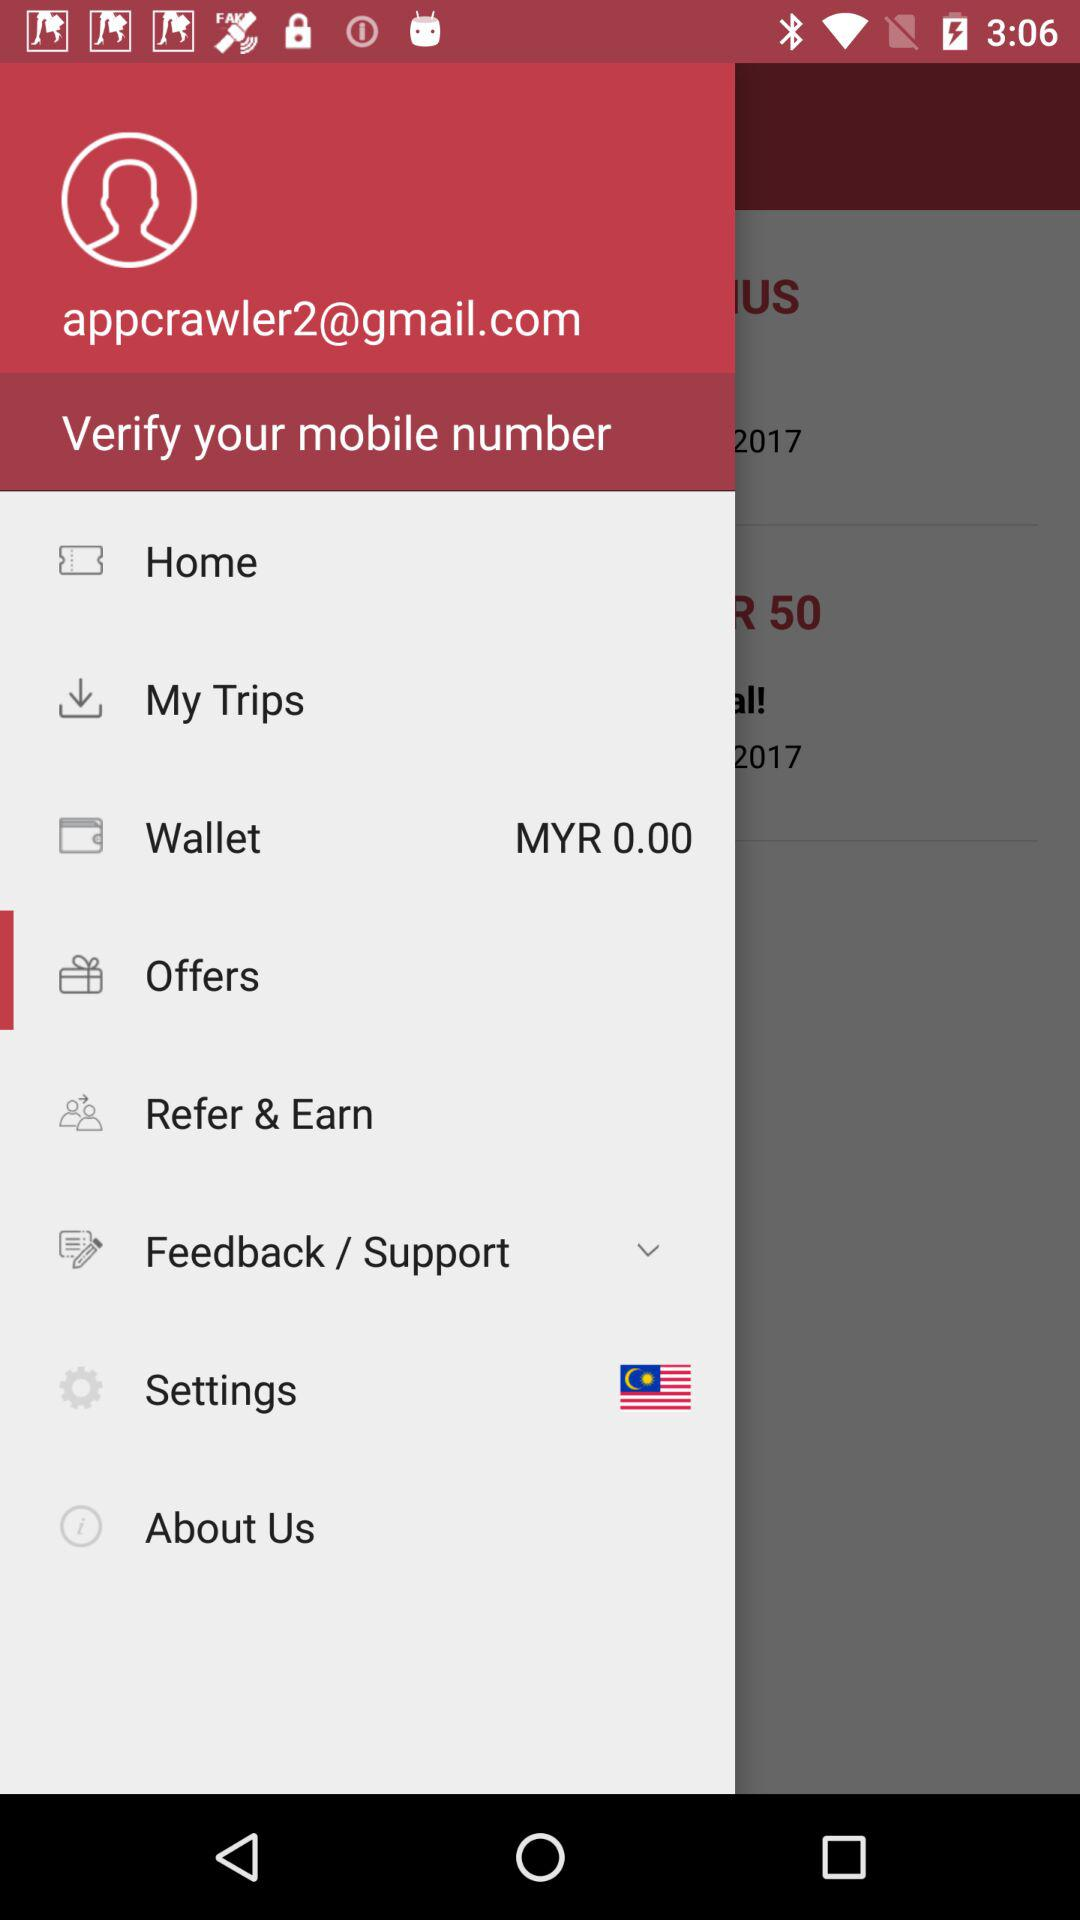How much money is in the user's wallet? The money in the user's wallet is MYR 0.00. 